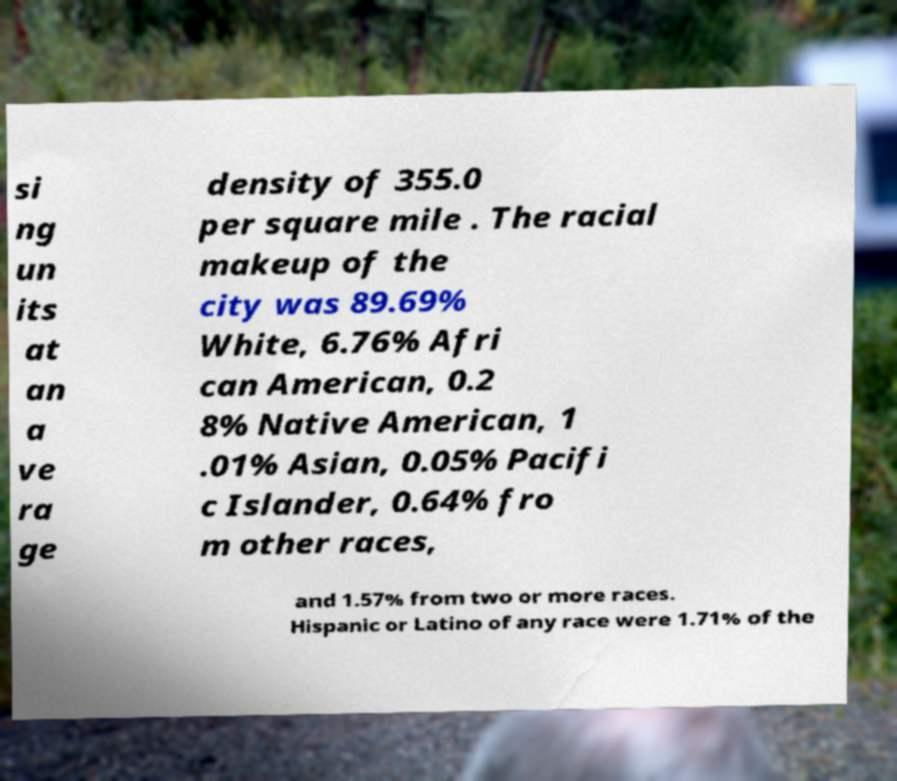For documentation purposes, I need the text within this image transcribed. Could you provide that? si ng un its at an a ve ra ge density of 355.0 per square mile . The racial makeup of the city was 89.69% White, 6.76% Afri can American, 0.2 8% Native American, 1 .01% Asian, 0.05% Pacifi c Islander, 0.64% fro m other races, and 1.57% from two or more races. Hispanic or Latino of any race were 1.71% of the 